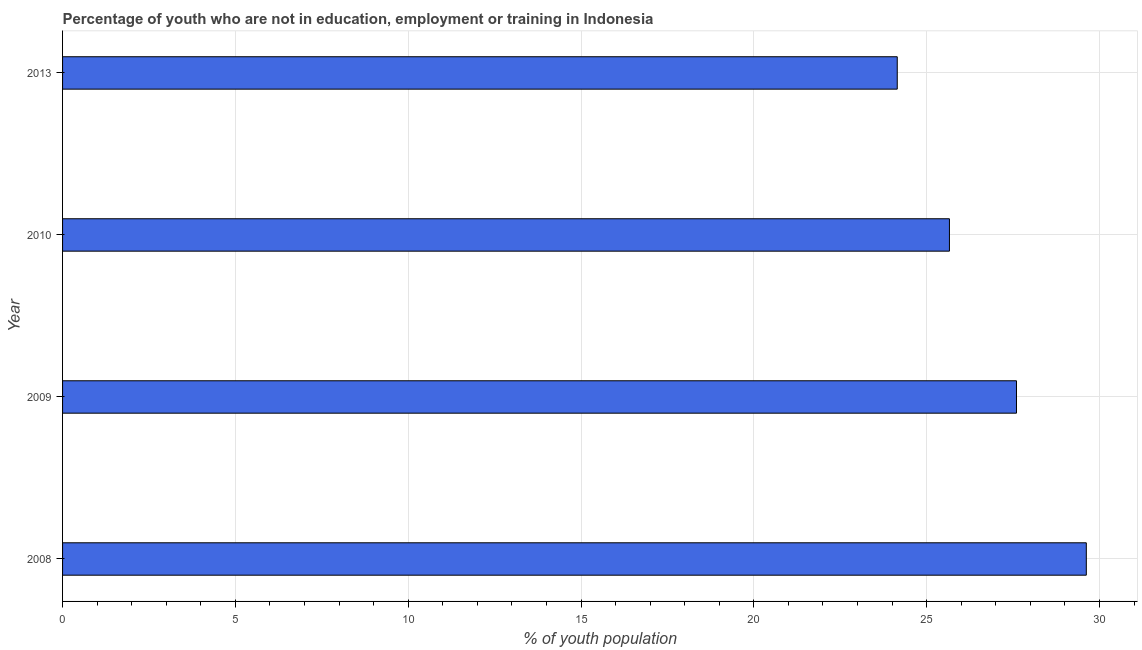What is the title of the graph?
Ensure brevity in your answer.  Percentage of youth who are not in education, employment or training in Indonesia. What is the label or title of the X-axis?
Your answer should be very brief. % of youth population. What is the unemployed youth population in 2013?
Offer a terse response. 24.15. Across all years, what is the maximum unemployed youth population?
Keep it short and to the point. 29.62. Across all years, what is the minimum unemployed youth population?
Your answer should be very brief. 24.15. In which year was the unemployed youth population maximum?
Make the answer very short. 2008. In which year was the unemployed youth population minimum?
Ensure brevity in your answer.  2013. What is the sum of the unemployed youth population?
Provide a succinct answer. 107.03. What is the difference between the unemployed youth population in 2008 and 2013?
Keep it short and to the point. 5.47. What is the average unemployed youth population per year?
Ensure brevity in your answer.  26.76. What is the median unemployed youth population?
Give a very brief answer. 26.63. In how many years, is the unemployed youth population greater than 5 %?
Your response must be concise. 4. Do a majority of the years between 2010 and 2013 (inclusive) have unemployed youth population greater than 22 %?
Your answer should be very brief. Yes. What is the ratio of the unemployed youth population in 2009 to that in 2013?
Make the answer very short. 1.14. What is the difference between the highest and the second highest unemployed youth population?
Give a very brief answer. 2.02. What is the difference between the highest and the lowest unemployed youth population?
Your answer should be compact. 5.47. In how many years, is the unemployed youth population greater than the average unemployed youth population taken over all years?
Provide a succinct answer. 2. How many bars are there?
Your answer should be compact. 4. What is the % of youth population of 2008?
Offer a terse response. 29.62. What is the % of youth population in 2009?
Your answer should be very brief. 27.6. What is the % of youth population of 2010?
Your response must be concise. 25.66. What is the % of youth population in 2013?
Make the answer very short. 24.15. What is the difference between the % of youth population in 2008 and 2009?
Offer a very short reply. 2.02. What is the difference between the % of youth population in 2008 and 2010?
Provide a succinct answer. 3.96. What is the difference between the % of youth population in 2008 and 2013?
Your answer should be very brief. 5.47. What is the difference between the % of youth population in 2009 and 2010?
Offer a very short reply. 1.94. What is the difference between the % of youth population in 2009 and 2013?
Your answer should be very brief. 3.45. What is the difference between the % of youth population in 2010 and 2013?
Offer a terse response. 1.51. What is the ratio of the % of youth population in 2008 to that in 2009?
Provide a short and direct response. 1.07. What is the ratio of the % of youth population in 2008 to that in 2010?
Give a very brief answer. 1.15. What is the ratio of the % of youth population in 2008 to that in 2013?
Your response must be concise. 1.23. What is the ratio of the % of youth population in 2009 to that in 2010?
Provide a short and direct response. 1.08. What is the ratio of the % of youth population in 2009 to that in 2013?
Keep it short and to the point. 1.14. What is the ratio of the % of youth population in 2010 to that in 2013?
Ensure brevity in your answer.  1.06. 